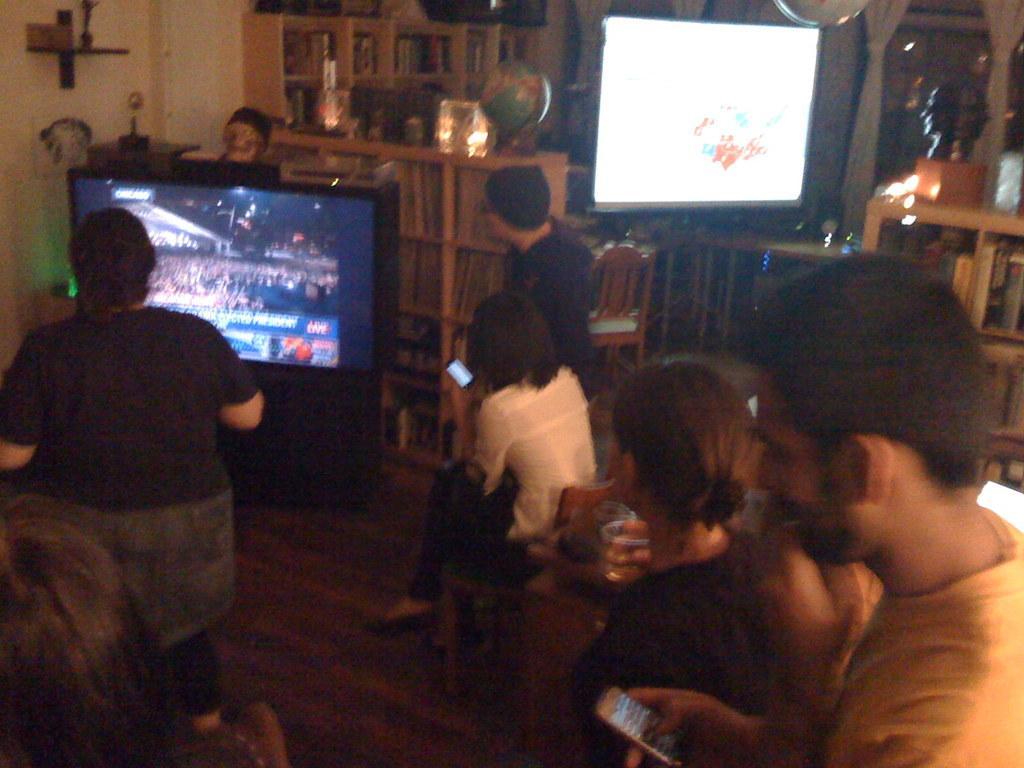How would you summarize this image in a sentence or two? In the image we can see there are people sitting and some of them are standing, they are wearing clothes. Here we can see screen and the floor. We can even see the window, curtains and lights. Here we can see shelves and there are books on the shelf. We can even see the chairs. 